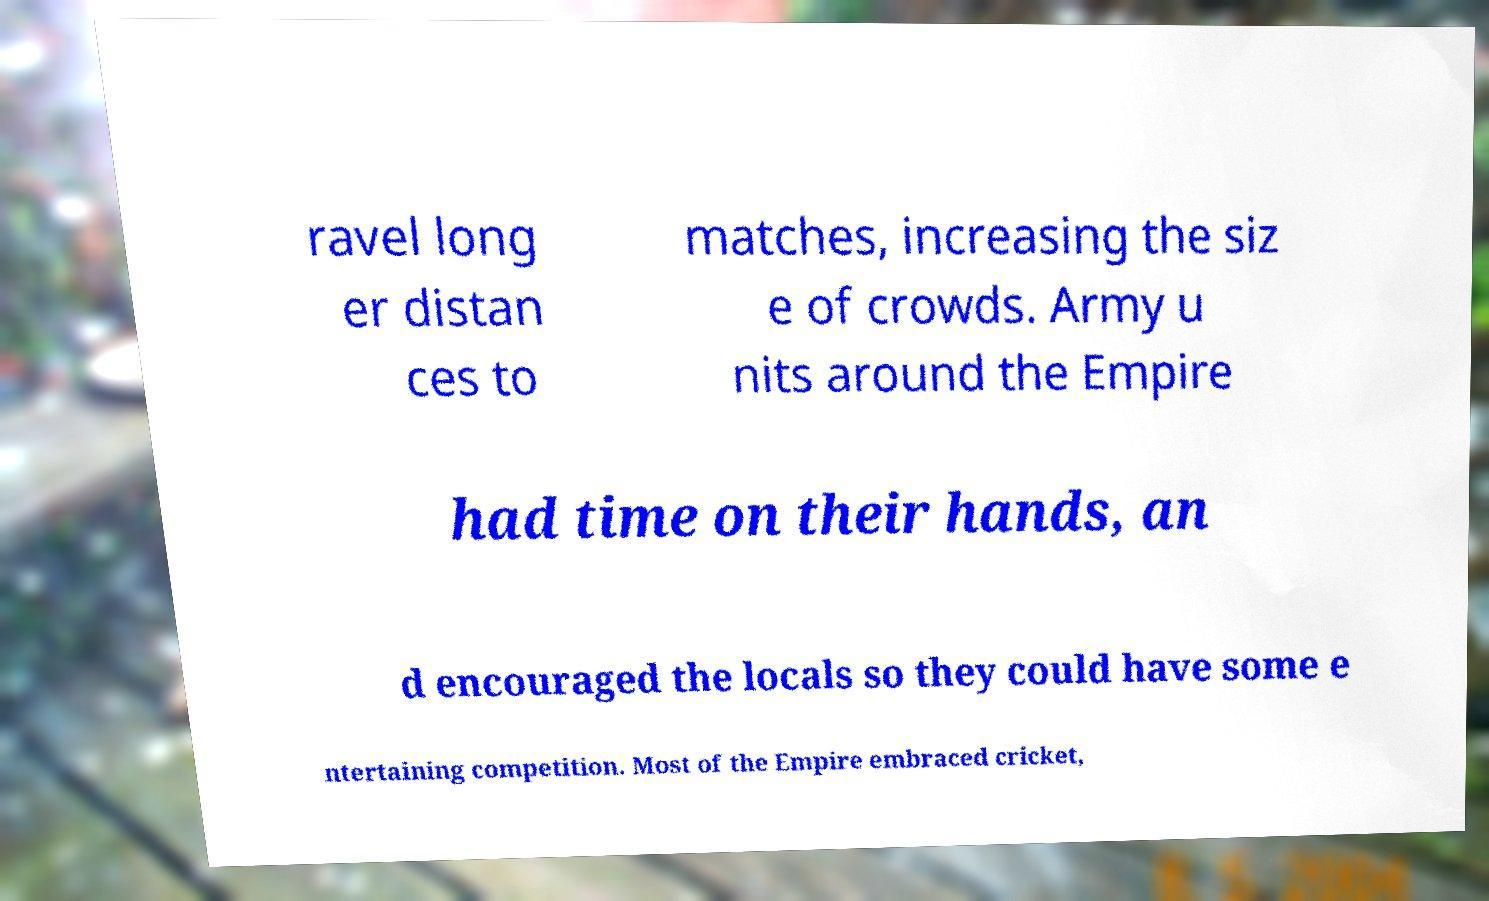Please read and relay the text visible in this image. What does it say? ravel long er distan ces to matches, increasing the siz e of crowds. Army u nits around the Empire had time on their hands, an d encouraged the locals so they could have some e ntertaining competition. Most of the Empire embraced cricket, 